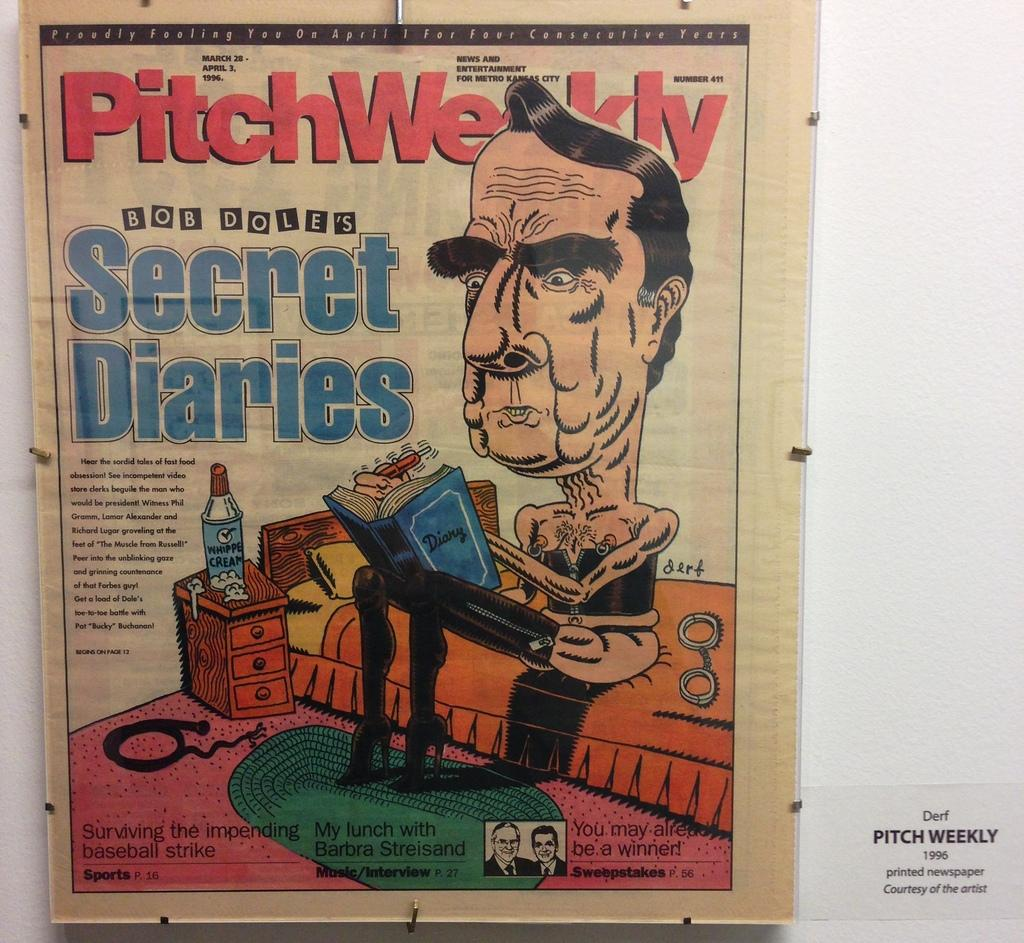<image>
Present a compact description of the photo's key features. A clipping from  PitchWeekly by Bob Dole's of Secret Diaries. 